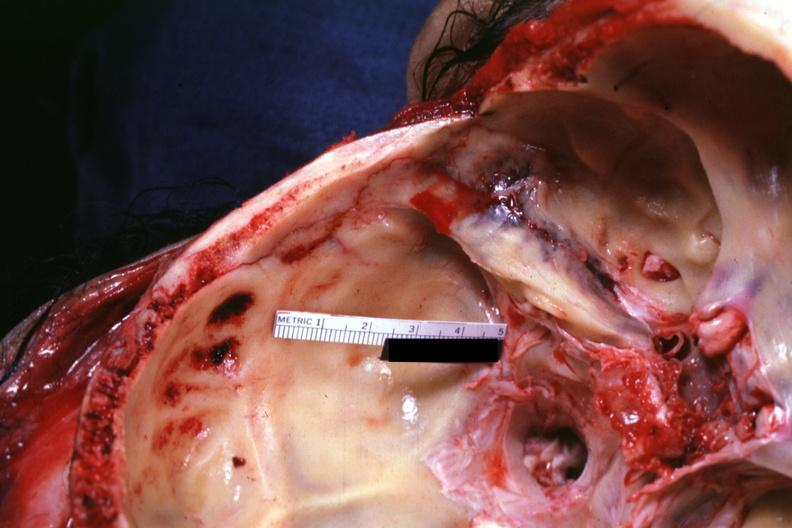s bone, calvarium present?
Answer the question using a single word or phrase. Yes 